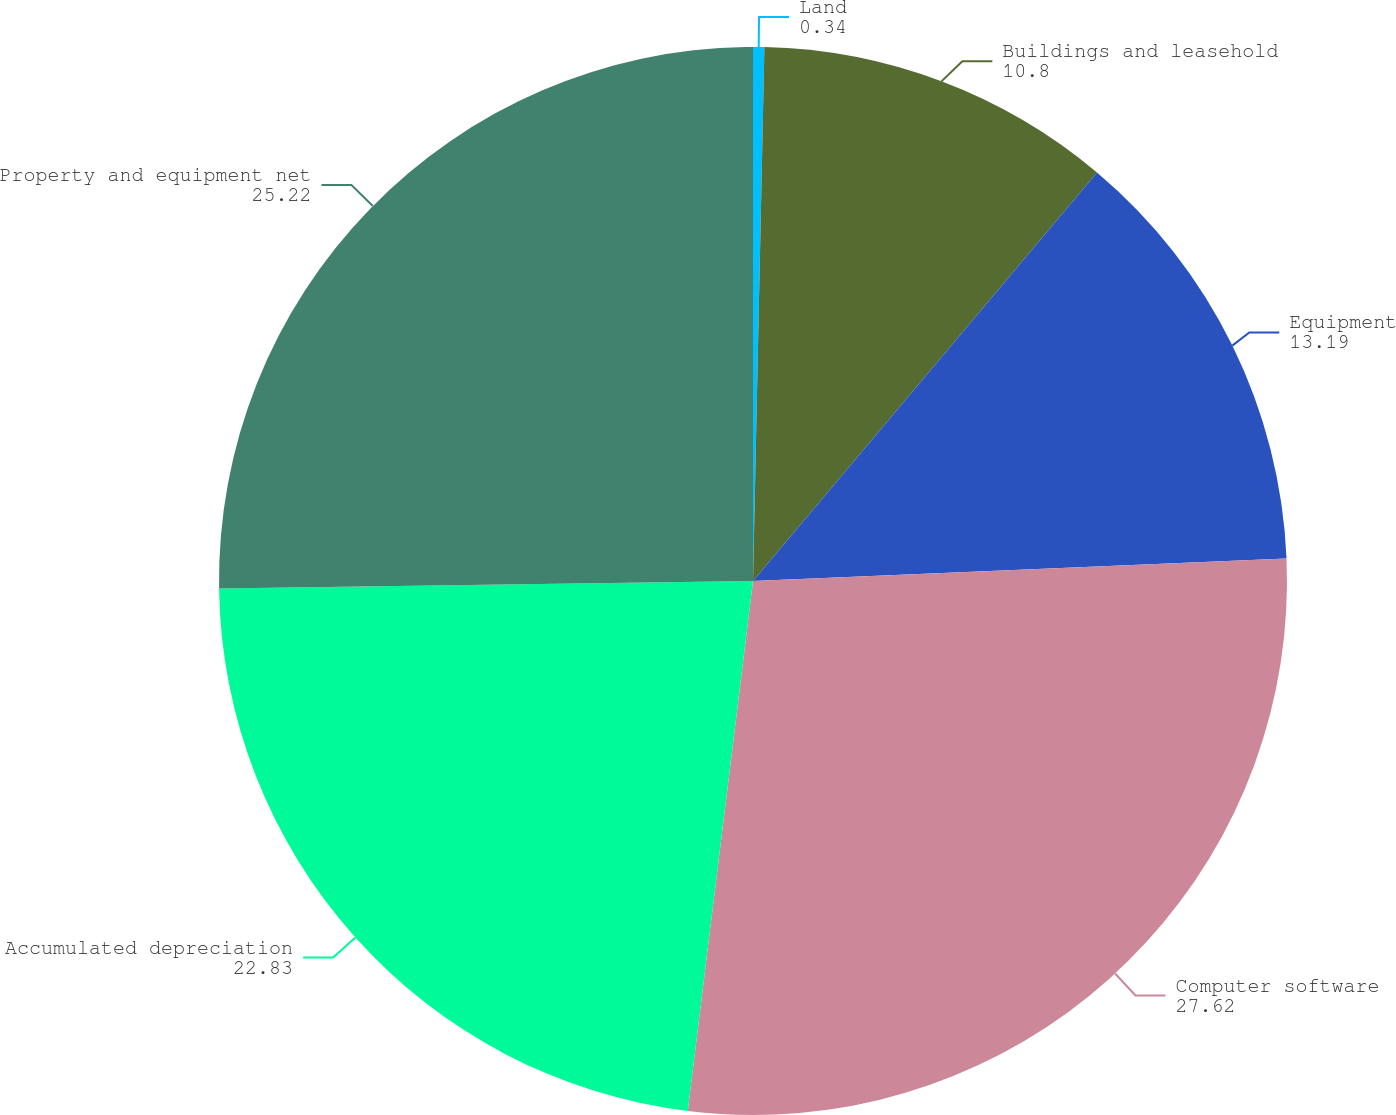Convert chart to OTSL. <chart><loc_0><loc_0><loc_500><loc_500><pie_chart><fcel>Land<fcel>Buildings and leasehold<fcel>Equipment<fcel>Computer software<fcel>Accumulated depreciation<fcel>Property and equipment net<nl><fcel>0.34%<fcel>10.8%<fcel>13.19%<fcel>27.62%<fcel>22.83%<fcel>25.22%<nl></chart> 